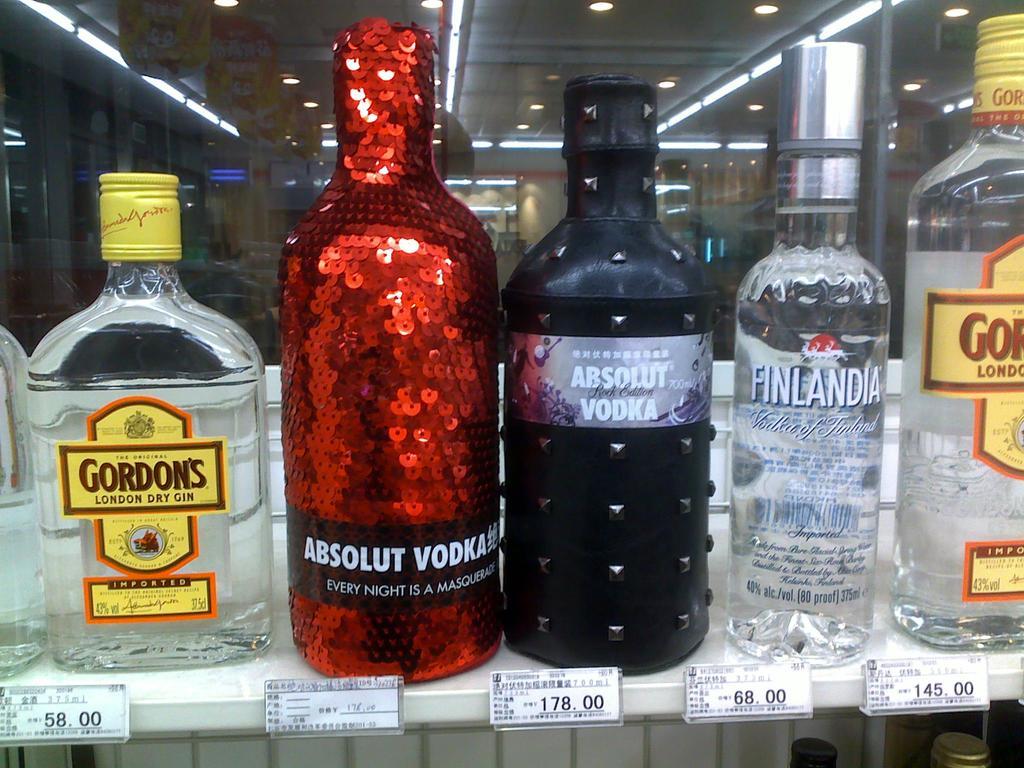What kind of liquor is this?
Your answer should be very brief. Vodka. What type of liquor is the red bottle?
Provide a succinct answer. Absolut vodka. 